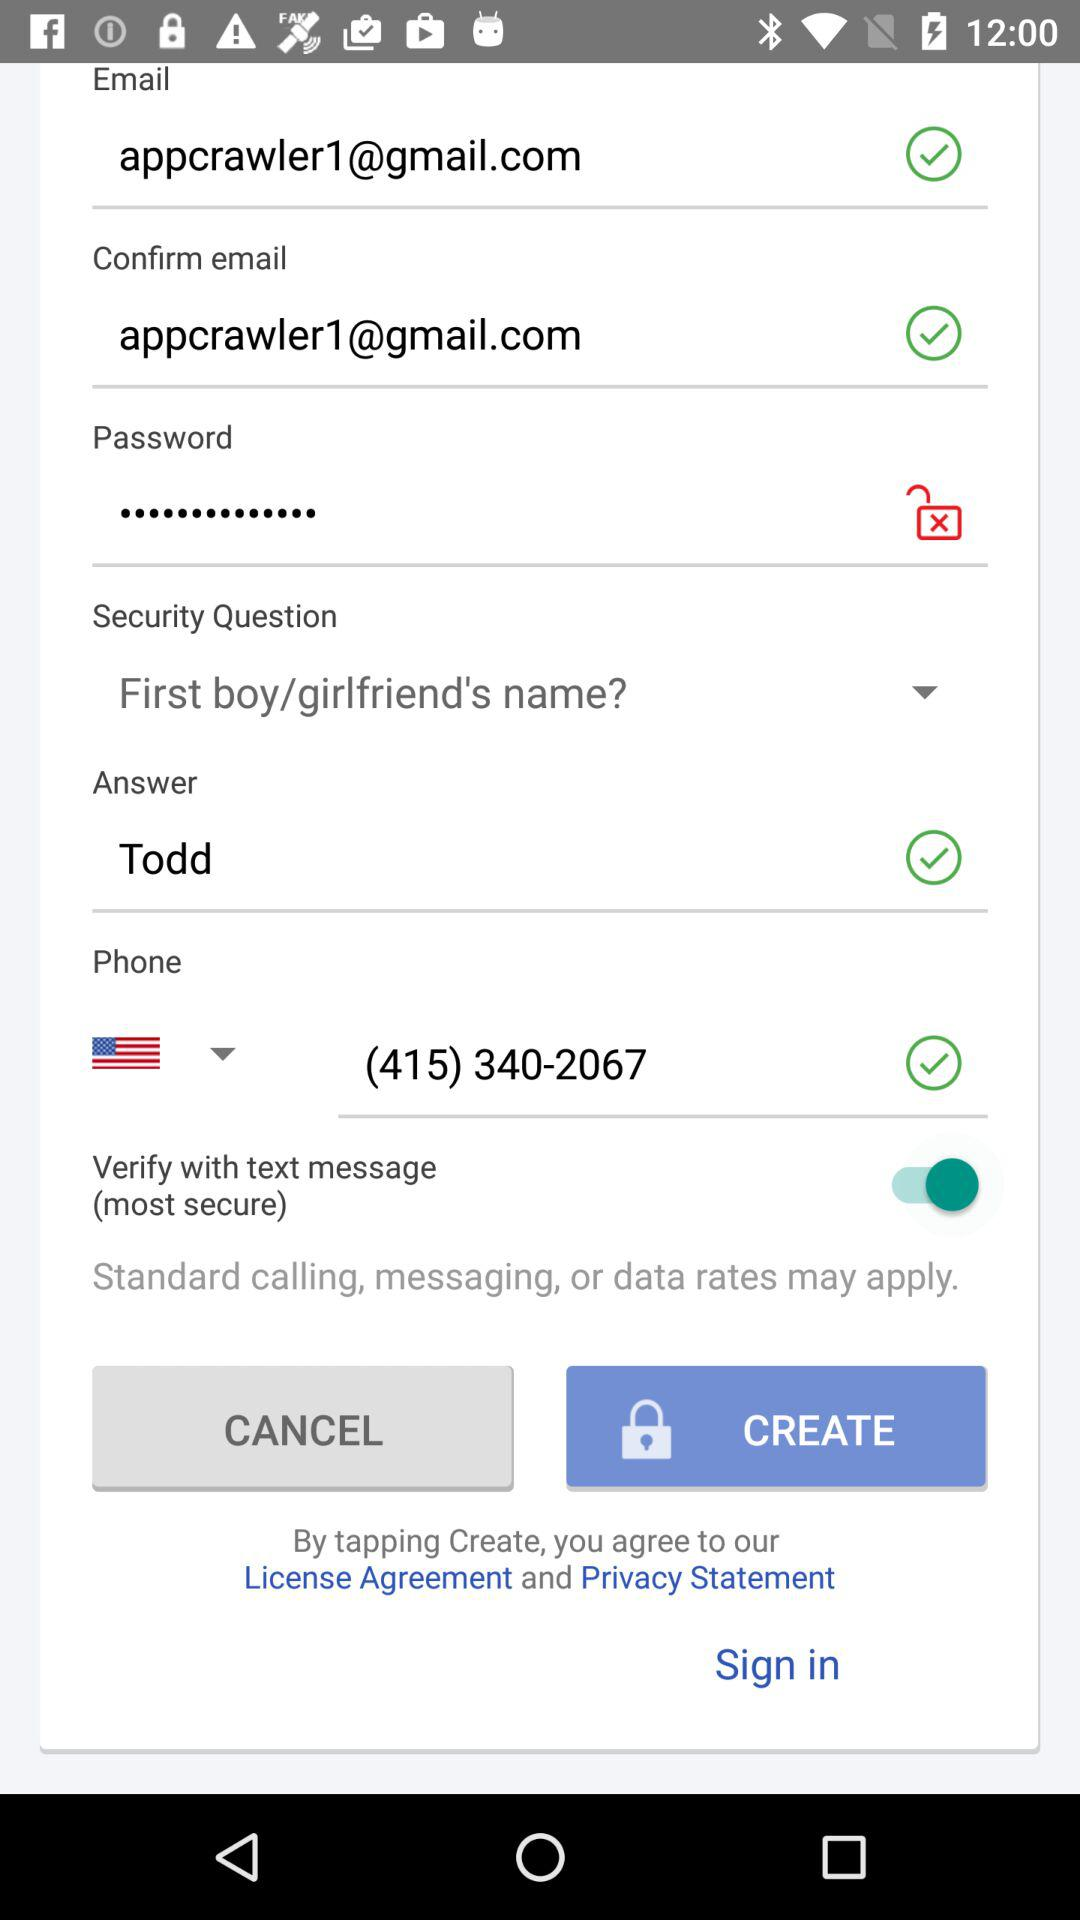What is the phone number? The phone number is (415) 340-2067. 